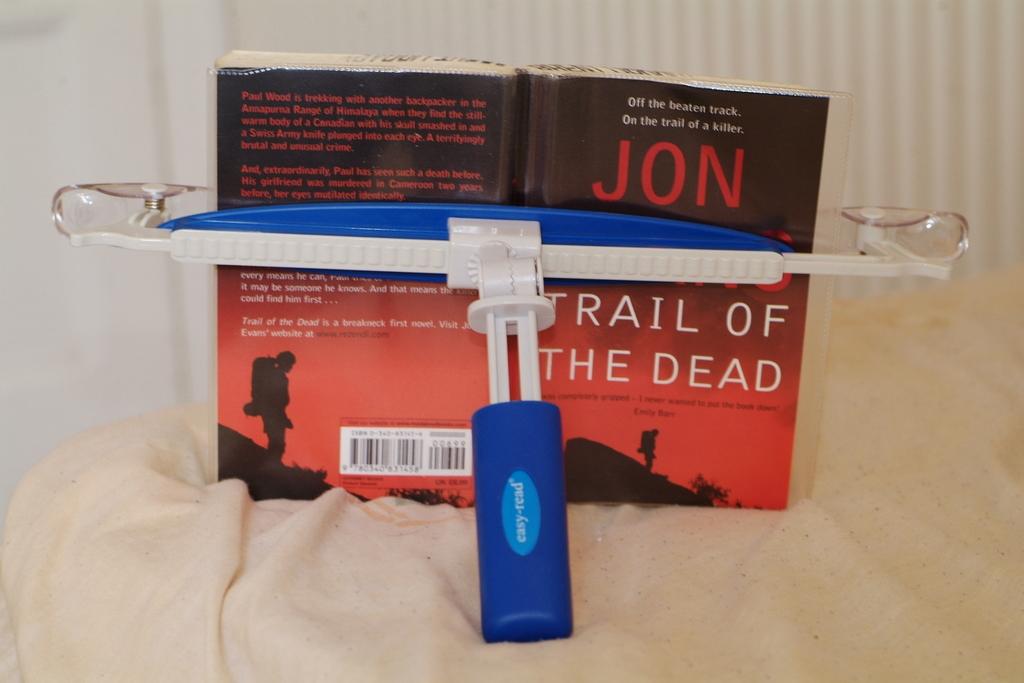Who is the author for this book ?
Your answer should be compact. Jon. What is the title of the book?
Offer a terse response. Trail of the dead. 